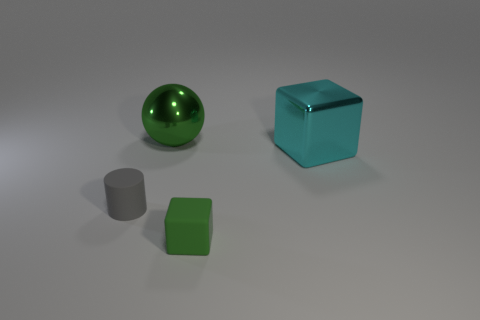Add 2 red rubber objects. How many objects exist? 6 Subtract all green cubes. How many cubes are left? 1 Add 3 tiny rubber cubes. How many tiny rubber cubes are left? 4 Add 3 cyan objects. How many cyan objects exist? 4 Subtract 0 blue blocks. How many objects are left? 4 Subtract all cylinders. How many objects are left? 3 Subtract all cyan blocks. Subtract all cyan spheres. How many blocks are left? 1 Subtract all blue cylinders. How many cyan cubes are left? 1 Subtract all small gray rubber cylinders. Subtract all balls. How many objects are left? 2 